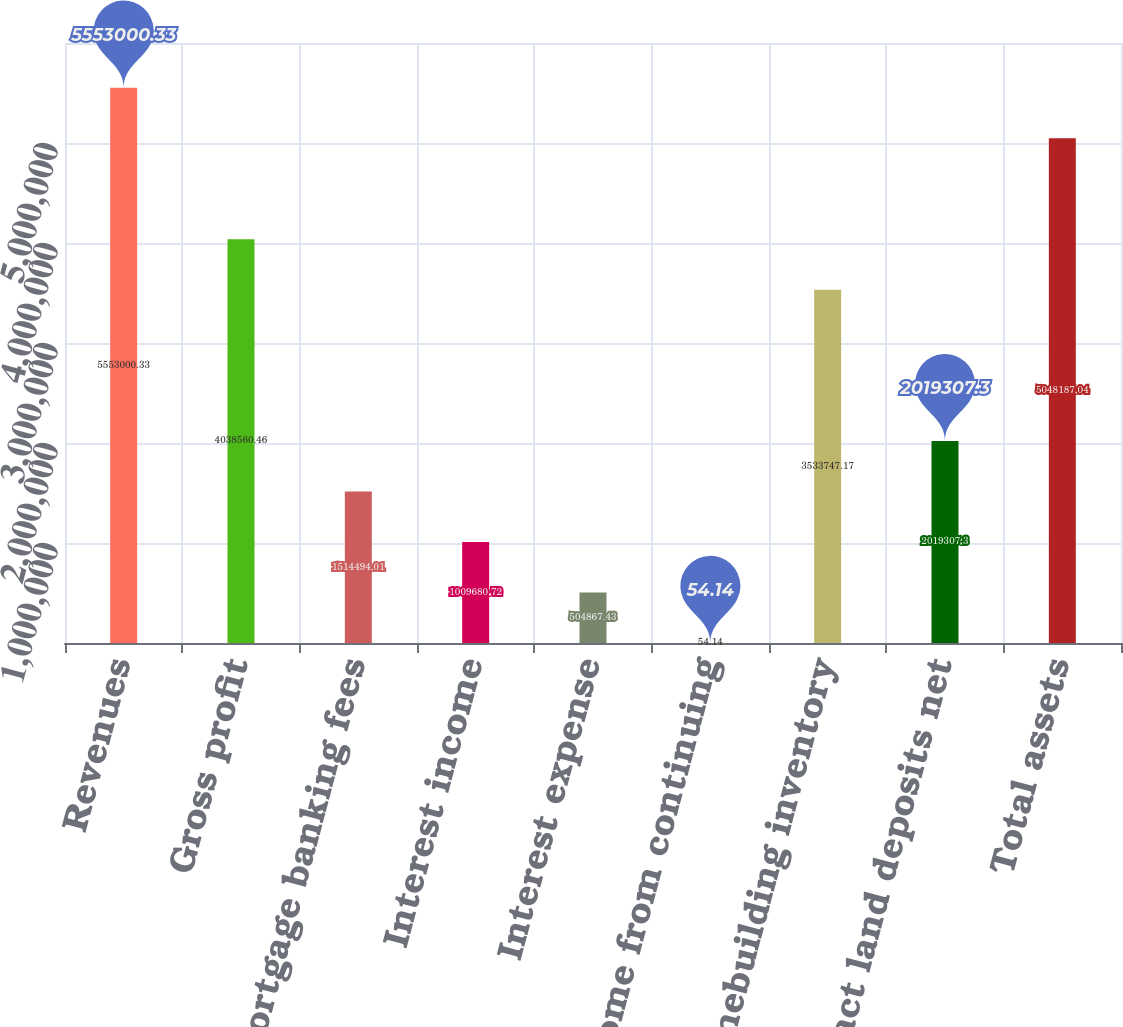Convert chart. <chart><loc_0><loc_0><loc_500><loc_500><bar_chart><fcel>Revenues<fcel>Gross profit<fcel>Mortgage banking fees<fcel>Interest income<fcel>Interest expense<fcel>Income from continuing<fcel>Homebuilding inventory<fcel>Contract land deposits net<fcel>Total assets<nl><fcel>5.553e+06<fcel>4.03856e+06<fcel>1.51449e+06<fcel>1.00968e+06<fcel>504867<fcel>54.14<fcel>3.53375e+06<fcel>2.01931e+06<fcel>5.04819e+06<nl></chart> 